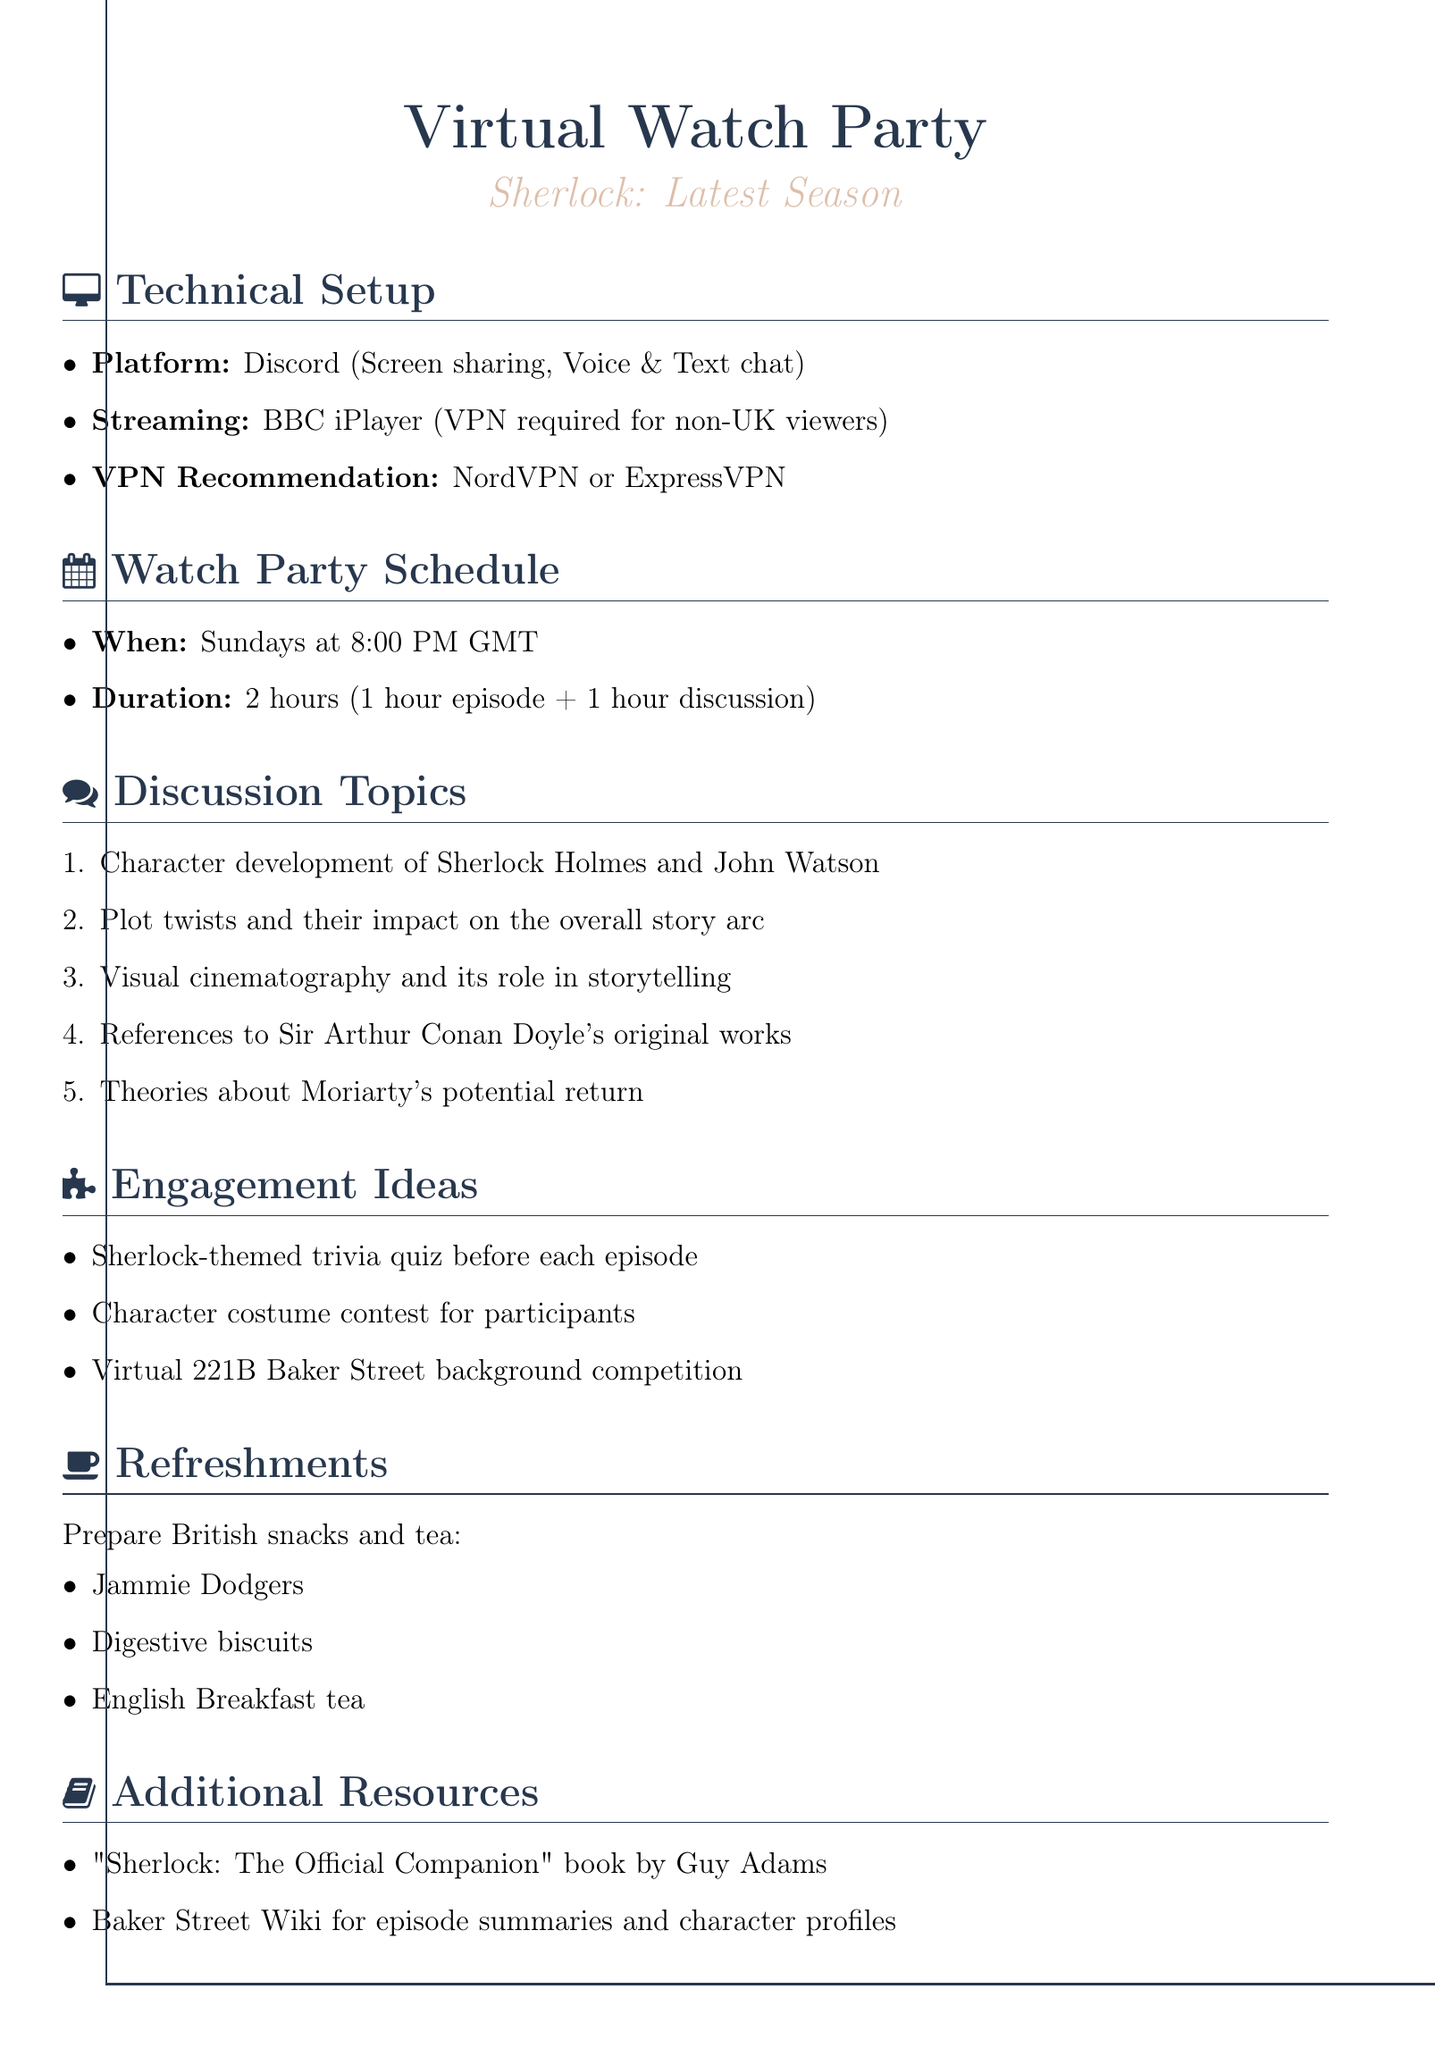What platform is recommended for the watch party? The document states that Discord is the platform recommended for the watch party due to its features.
Answer: Discord What is the maximum duration of the watch party? The document specifies that the total duration of the watch party is 2 hours, consisting of 1 hour for the episode and 1 hour for discussion.
Answer: 2 hours On which day of the week will the watch party be held? The document indicates that the watch party is scheduled to happen on Sundays.
Answer: Sundays What are the suggested refreshments for the party? The document lists British snacks and tea, with examples provided, therefore it refers specifically to Jammie Dodgers, Digestive biscuits, and English Breakfast tea.
Answer: Jammie Dodgers, Digestive biscuits, English Breakfast tea Which VPNs are recommended for non-UK viewers? The document mentions specific VPN services that are recommended for non-UK viewers to access BBC iPlayer, which are NordVPN or ExpressVPN.
Answer: NordVPN or ExpressVPN What discussion topic involves examining the characters? The document includes a topic focused on character development, specifically mentioning Sherlock Holmes and John Watson, as one of the key discussion points.
Answer: Character development of Sherlock Holmes and John Watson What engagement activity is suggested to take place before each episode? The document elaborates that there will be a Sherlock-themed trivia quiz organized before each episode to enhance engagement.
Answer: Sherlock-themed trivia quiz How often will the watch party occur? The document states the frequency of the watch parties, which are planned to be weekly.
Answer: Weekly 